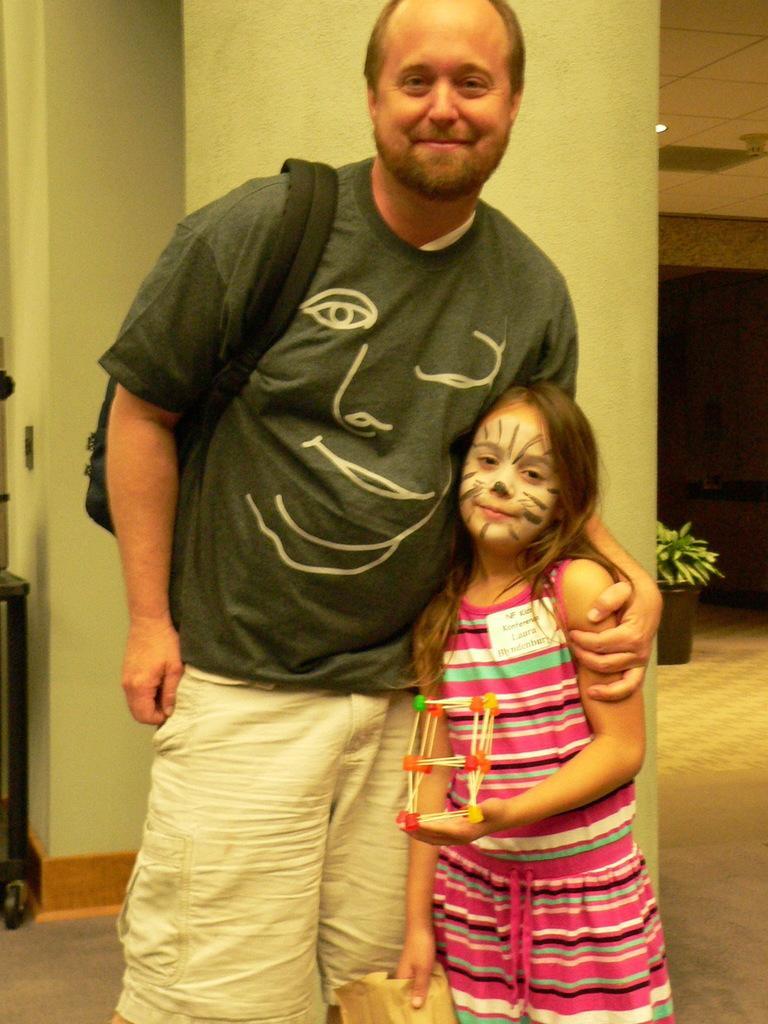In one or two sentences, can you explain what this image depicts? In the foreground I can see two persons are standing on the floor and are holding some objects in their hand. In the background I can see a pillar, wall, houseplant, door and rooftop. This image is taken may be in a building. 